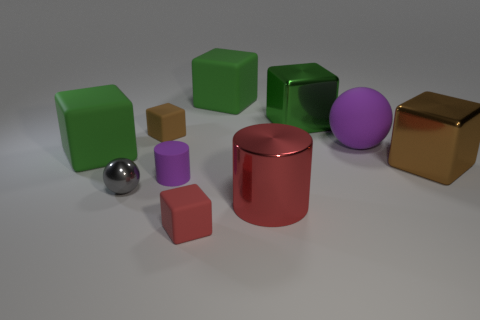How many green cubes must be subtracted to get 1 green cubes? 2 Subtract all purple cylinders. How many green cubes are left? 3 Subtract all red blocks. How many blocks are left? 5 Subtract all big brown shiny blocks. How many blocks are left? 5 Subtract all blue cubes. Subtract all cyan cylinders. How many cubes are left? 6 Subtract all balls. How many objects are left? 8 Subtract 0 green cylinders. How many objects are left? 10 Subtract all large green objects. Subtract all large red things. How many objects are left? 6 Add 8 green shiny cubes. How many green shiny cubes are left? 9 Add 3 tiny brown matte spheres. How many tiny brown matte spheres exist? 3 